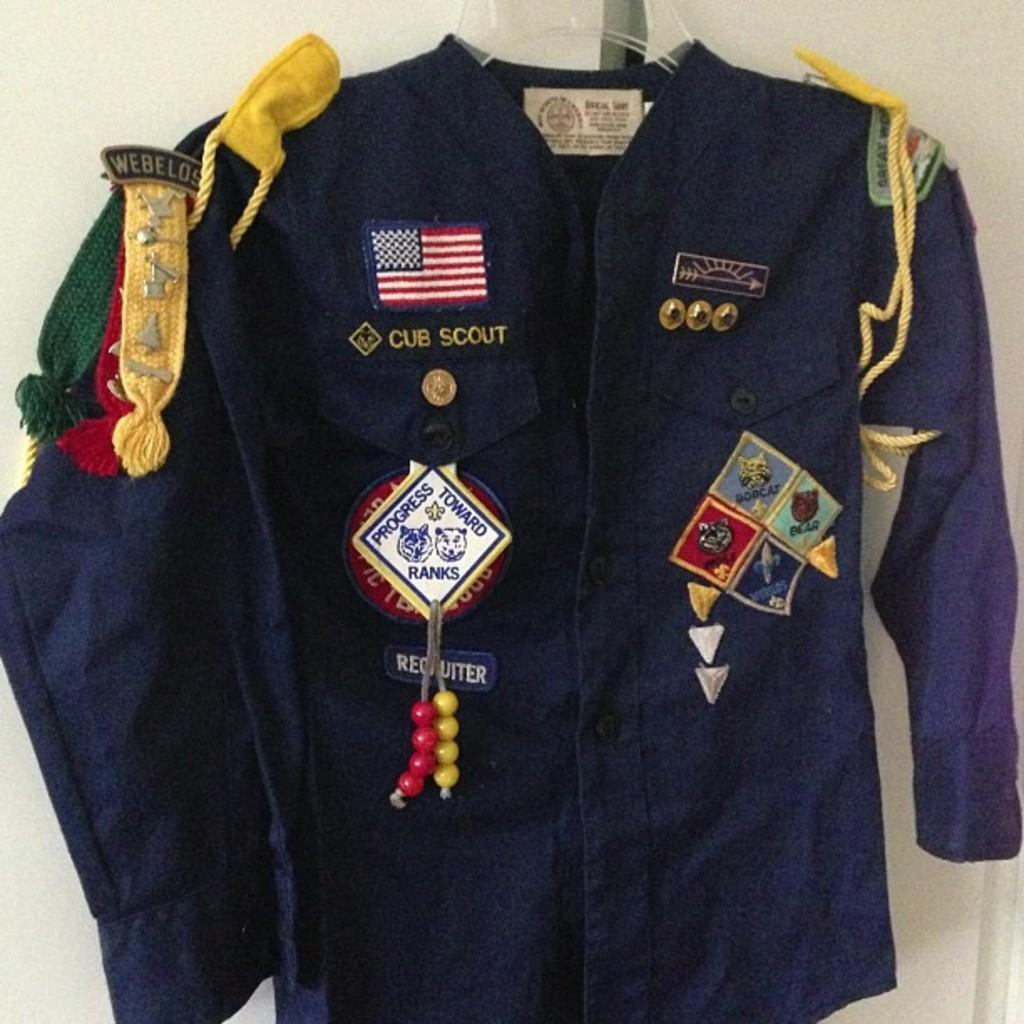<image>
Offer a succinct explanation of the picture presented. Blue jacket that has the words Cub Scout on it. 